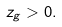Convert formula to latex. <formula><loc_0><loc_0><loc_500><loc_500>z _ { g } > 0 .</formula> 